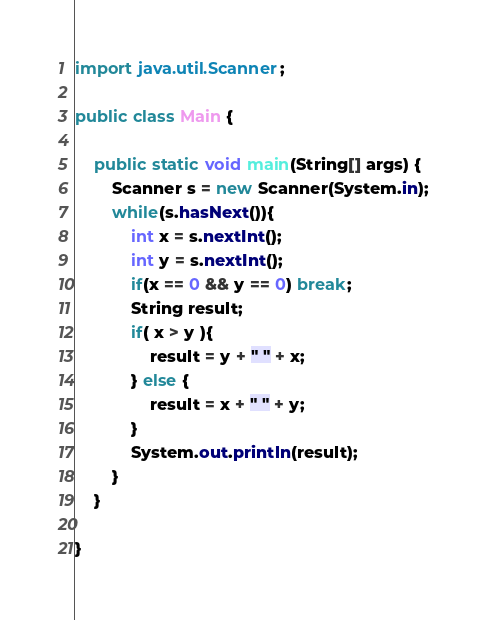<code> <loc_0><loc_0><loc_500><loc_500><_Java_>import java.util.Scanner;

public class Main {

    public static void main(String[] args) {
        Scanner s = new Scanner(System.in);
        while(s.hasNext()){
            int x = s.nextInt();
            int y = s.nextInt();
            if(x == 0 && y == 0) break;
            String result;
            if( x > y ){
                result = y + " " + x;
            } else {
                result = x + " " + y;
            }
            System.out.println(result);
        }
    }

}</code> 